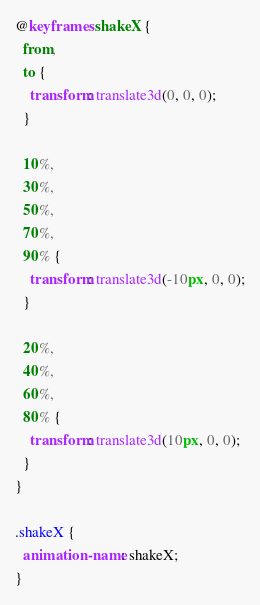Convert code to text. <code><loc_0><loc_0><loc_500><loc_500><_CSS_>@keyframes shakeX {
  from,
  to {
    transform: translate3d(0, 0, 0);
  }

  10%,
  30%,
  50%,
  70%,
  90% {
    transform: translate3d(-10px, 0, 0);
  }

  20%,
  40%,
  60%,
  80% {
    transform: translate3d(10px, 0, 0);
  }
}

.shakeX {
  animation-name: shakeX;
}
</code> 